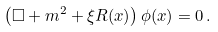<formula> <loc_0><loc_0><loc_500><loc_500>\left ( \square + m ^ { 2 } + \xi R ( x ) \right ) \phi ( x ) = 0 \, .</formula> 